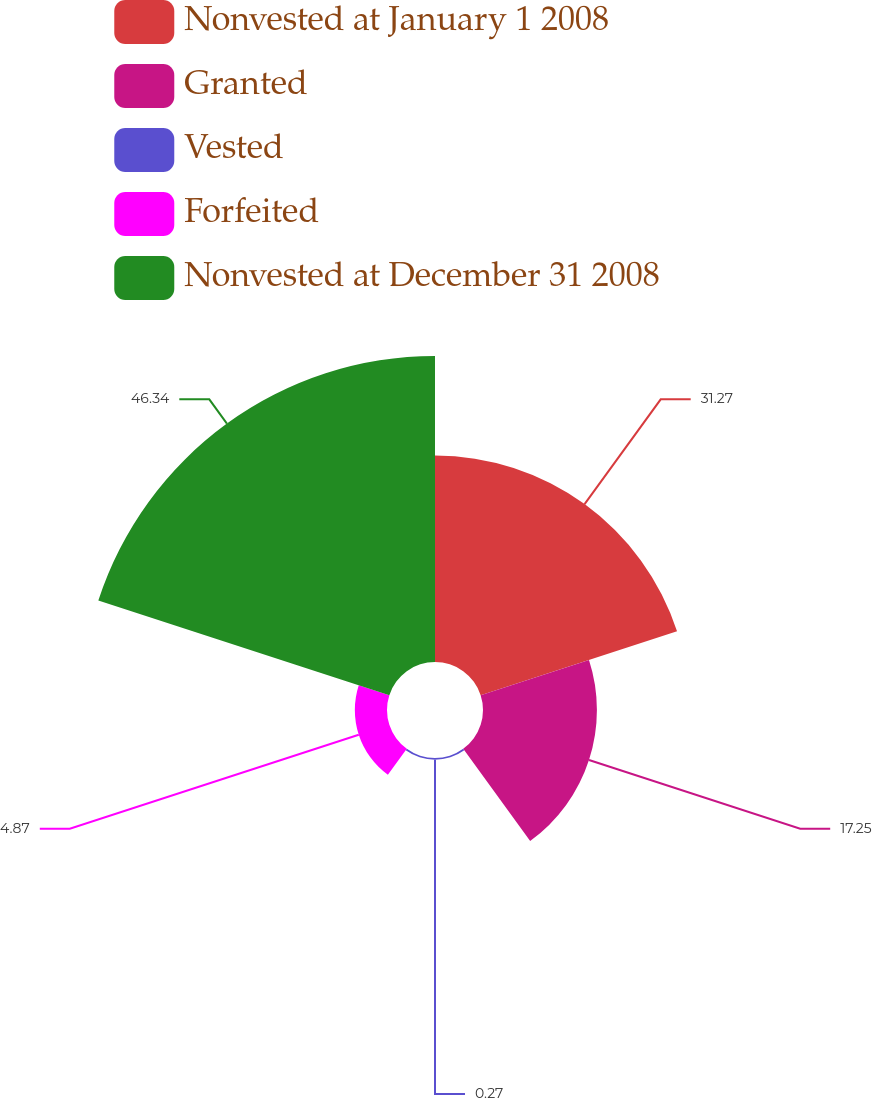<chart> <loc_0><loc_0><loc_500><loc_500><pie_chart><fcel>Nonvested at January 1 2008<fcel>Granted<fcel>Vested<fcel>Forfeited<fcel>Nonvested at December 31 2008<nl><fcel>31.27%<fcel>17.25%<fcel>0.27%<fcel>4.87%<fcel>46.34%<nl></chart> 